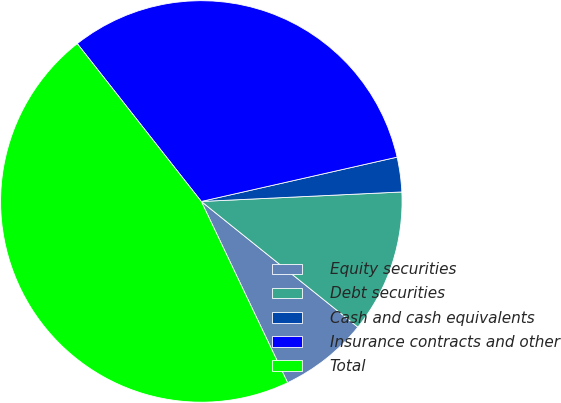Convert chart. <chart><loc_0><loc_0><loc_500><loc_500><pie_chart><fcel>Equity securities<fcel>Debt securities<fcel>Cash and cash equivalents<fcel>Insurance contracts and other<fcel>Total<nl><fcel>7.16%<fcel>11.52%<fcel>2.79%<fcel>32.06%<fcel>46.47%<nl></chart> 